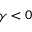<formula> <loc_0><loc_0><loc_500><loc_500>\gamma < 0</formula> 